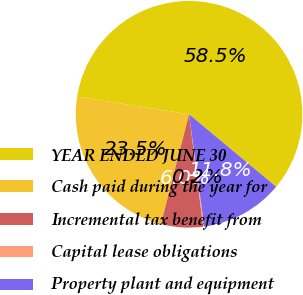Convert chart to OTSL. <chart><loc_0><loc_0><loc_500><loc_500><pie_chart><fcel>YEAR ENDED JUNE 30<fcel>Cash paid during the year for<fcel>Incremental tax benefit from<fcel>Capital lease obligations<fcel>Property plant and equipment<nl><fcel>58.54%<fcel>23.5%<fcel>5.98%<fcel>0.15%<fcel>11.82%<nl></chart> 